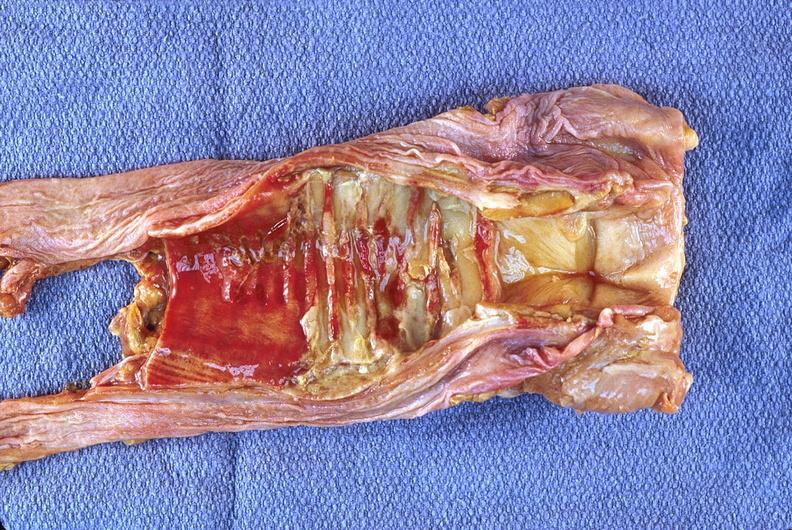what does this image show?
Answer the question using a single word or phrase. Trachea 